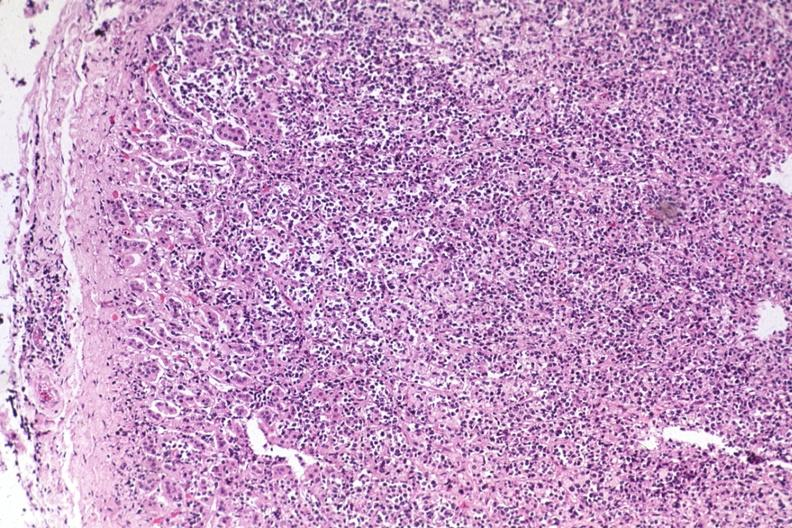what is present?
Answer the question using a single word or phrase. Adrenal 